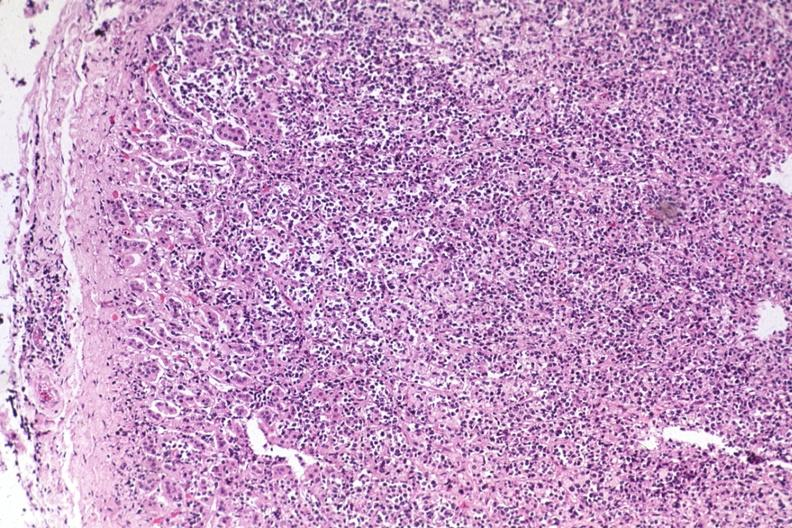what is present?
Answer the question using a single word or phrase. Adrenal 